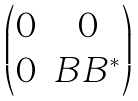<formula> <loc_0><loc_0><loc_500><loc_500>\begin{pmatrix} 0 & 0 \\ 0 & B B ^ { \ast } \end{pmatrix}</formula> 